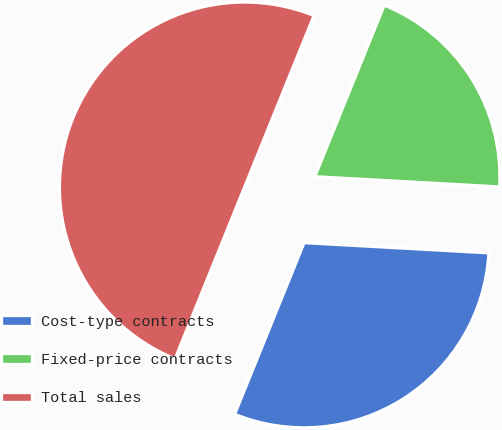Convert chart to OTSL. <chart><loc_0><loc_0><loc_500><loc_500><pie_chart><fcel>Cost-type contracts<fcel>Fixed-price contracts<fcel>Total sales<nl><fcel>30.24%<fcel>19.76%<fcel>50.0%<nl></chart> 